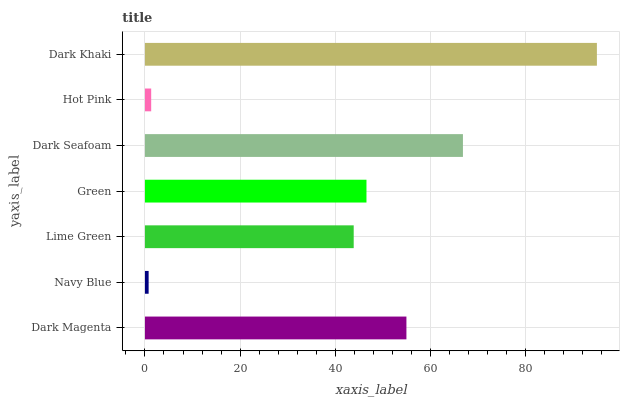Is Navy Blue the minimum?
Answer yes or no. Yes. Is Dark Khaki the maximum?
Answer yes or no. Yes. Is Lime Green the minimum?
Answer yes or no. No. Is Lime Green the maximum?
Answer yes or no. No. Is Lime Green greater than Navy Blue?
Answer yes or no. Yes. Is Navy Blue less than Lime Green?
Answer yes or no. Yes. Is Navy Blue greater than Lime Green?
Answer yes or no. No. Is Lime Green less than Navy Blue?
Answer yes or no. No. Is Green the high median?
Answer yes or no. Yes. Is Green the low median?
Answer yes or no. Yes. Is Hot Pink the high median?
Answer yes or no. No. Is Navy Blue the low median?
Answer yes or no. No. 